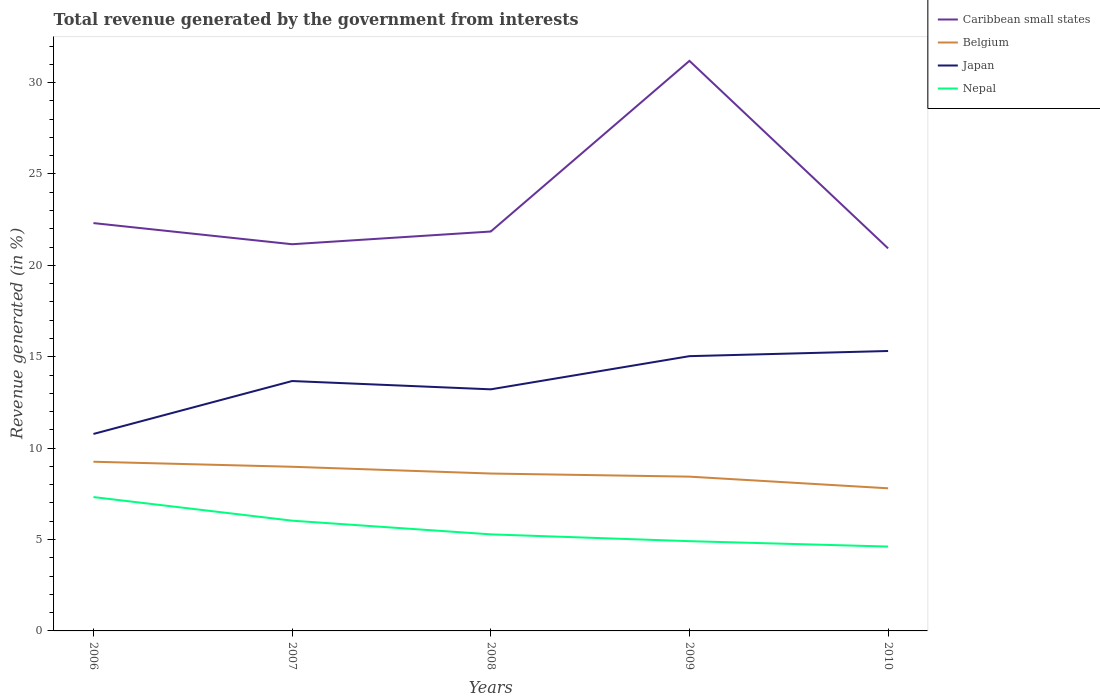How many different coloured lines are there?
Offer a very short reply. 4. Does the line corresponding to Belgium intersect with the line corresponding to Japan?
Your response must be concise. No. Is the number of lines equal to the number of legend labels?
Your answer should be compact. Yes. Across all years, what is the maximum total revenue generated in Caribbean small states?
Offer a terse response. 20.93. In which year was the total revenue generated in Nepal maximum?
Your response must be concise. 2010. What is the total total revenue generated in Caribbean small states in the graph?
Your response must be concise. 1.38. What is the difference between the highest and the second highest total revenue generated in Nepal?
Offer a very short reply. 2.71. Is the total revenue generated in Belgium strictly greater than the total revenue generated in Japan over the years?
Your answer should be very brief. Yes. How many lines are there?
Offer a terse response. 4. What is the difference between two consecutive major ticks on the Y-axis?
Provide a succinct answer. 5. Are the values on the major ticks of Y-axis written in scientific E-notation?
Provide a short and direct response. No. Does the graph contain any zero values?
Offer a very short reply. No. Where does the legend appear in the graph?
Your answer should be compact. Top right. How many legend labels are there?
Your answer should be compact. 4. What is the title of the graph?
Ensure brevity in your answer.  Total revenue generated by the government from interests. What is the label or title of the Y-axis?
Ensure brevity in your answer.  Revenue generated (in %). What is the Revenue generated (in %) in Caribbean small states in 2006?
Provide a short and direct response. 22.31. What is the Revenue generated (in %) of Belgium in 2006?
Offer a very short reply. 9.26. What is the Revenue generated (in %) in Japan in 2006?
Your answer should be very brief. 10.78. What is the Revenue generated (in %) of Nepal in 2006?
Ensure brevity in your answer.  7.32. What is the Revenue generated (in %) in Caribbean small states in 2007?
Provide a succinct answer. 21.16. What is the Revenue generated (in %) of Belgium in 2007?
Provide a succinct answer. 8.98. What is the Revenue generated (in %) of Japan in 2007?
Your answer should be very brief. 13.67. What is the Revenue generated (in %) of Nepal in 2007?
Provide a short and direct response. 6.03. What is the Revenue generated (in %) of Caribbean small states in 2008?
Make the answer very short. 21.85. What is the Revenue generated (in %) in Belgium in 2008?
Provide a short and direct response. 8.61. What is the Revenue generated (in %) of Japan in 2008?
Your response must be concise. 13.22. What is the Revenue generated (in %) in Nepal in 2008?
Your answer should be very brief. 5.28. What is the Revenue generated (in %) in Caribbean small states in 2009?
Give a very brief answer. 31.19. What is the Revenue generated (in %) of Belgium in 2009?
Offer a terse response. 8.44. What is the Revenue generated (in %) in Japan in 2009?
Provide a succinct answer. 15.03. What is the Revenue generated (in %) of Nepal in 2009?
Your answer should be very brief. 4.91. What is the Revenue generated (in %) of Caribbean small states in 2010?
Your answer should be very brief. 20.93. What is the Revenue generated (in %) in Belgium in 2010?
Your answer should be compact. 7.8. What is the Revenue generated (in %) of Japan in 2010?
Your answer should be compact. 15.32. What is the Revenue generated (in %) in Nepal in 2010?
Make the answer very short. 4.62. Across all years, what is the maximum Revenue generated (in %) in Caribbean small states?
Provide a succinct answer. 31.19. Across all years, what is the maximum Revenue generated (in %) of Belgium?
Provide a short and direct response. 9.26. Across all years, what is the maximum Revenue generated (in %) in Japan?
Keep it short and to the point. 15.32. Across all years, what is the maximum Revenue generated (in %) of Nepal?
Your response must be concise. 7.32. Across all years, what is the minimum Revenue generated (in %) in Caribbean small states?
Ensure brevity in your answer.  20.93. Across all years, what is the minimum Revenue generated (in %) of Belgium?
Offer a terse response. 7.8. Across all years, what is the minimum Revenue generated (in %) of Japan?
Keep it short and to the point. 10.78. Across all years, what is the minimum Revenue generated (in %) in Nepal?
Offer a terse response. 4.62. What is the total Revenue generated (in %) of Caribbean small states in the graph?
Your answer should be very brief. 117.44. What is the total Revenue generated (in %) of Belgium in the graph?
Give a very brief answer. 43.09. What is the total Revenue generated (in %) of Japan in the graph?
Your answer should be compact. 68.01. What is the total Revenue generated (in %) of Nepal in the graph?
Offer a very short reply. 28.16. What is the difference between the Revenue generated (in %) in Caribbean small states in 2006 and that in 2007?
Offer a terse response. 1.16. What is the difference between the Revenue generated (in %) in Belgium in 2006 and that in 2007?
Your response must be concise. 0.28. What is the difference between the Revenue generated (in %) of Japan in 2006 and that in 2007?
Give a very brief answer. -2.9. What is the difference between the Revenue generated (in %) in Nepal in 2006 and that in 2007?
Your answer should be compact. 1.29. What is the difference between the Revenue generated (in %) in Caribbean small states in 2006 and that in 2008?
Keep it short and to the point. 0.46. What is the difference between the Revenue generated (in %) of Belgium in 2006 and that in 2008?
Give a very brief answer. 0.65. What is the difference between the Revenue generated (in %) in Japan in 2006 and that in 2008?
Provide a short and direct response. -2.44. What is the difference between the Revenue generated (in %) of Nepal in 2006 and that in 2008?
Your response must be concise. 2.04. What is the difference between the Revenue generated (in %) of Caribbean small states in 2006 and that in 2009?
Your answer should be compact. -8.88. What is the difference between the Revenue generated (in %) of Belgium in 2006 and that in 2009?
Your answer should be very brief. 0.82. What is the difference between the Revenue generated (in %) in Japan in 2006 and that in 2009?
Offer a very short reply. -4.26. What is the difference between the Revenue generated (in %) of Nepal in 2006 and that in 2009?
Your answer should be compact. 2.41. What is the difference between the Revenue generated (in %) of Caribbean small states in 2006 and that in 2010?
Give a very brief answer. 1.38. What is the difference between the Revenue generated (in %) in Belgium in 2006 and that in 2010?
Your answer should be very brief. 1.45. What is the difference between the Revenue generated (in %) in Japan in 2006 and that in 2010?
Give a very brief answer. -4.54. What is the difference between the Revenue generated (in %) in Nepal in 2006 and that in 2010?
Offer a terse response. 2.71. What is the difference between the Revenue generated (in %) in Caribbean small states in 2007 and that in 2008?
Offer a very short reply. -0.7. What is the difference between the Revenue generated (in %) in Belgium in 2007 and that in 2008?
Make the answer very short. 0.37. What is the difference between the Revenue generated (in %) in Japan in 2007 and that in 2008?
Give a very brief answer. 0.45. What is the difference between the Revenue generated (in %) of Nepal in 2007 and that in 2008?
Offer a very short reply. 0.75. What is the difference between the Revenue generated (in %) in Caribbean small states in 2007 and that in 2009?
Offer a very short reply. -10.03. What is the difference between the Revenue generated (in %) of Belgium in 2007 and that in 2009?
Your answer should be very brief. 0.54. What is the difference between the Revenue generated (in %) of Japan in 2007 and that in 2009?
Give a very brief answer. -1.36. What is the difference between the Revenue generated (in %) of Nepal in 2007 and that in 2009?
Provide a succinct answer. 1.12. What is the difference between the Revenue generated (in %) in Caribbean small states in 2007 and that in 2010?
Give a very brief answer. 0.23. What is the difference between the Revenue generated (in %) of Belgium in 2007 and that in 2010?
Make the answer very short. 1.18. What is the difference between the Revenue generated (in %) in Japan in 2007 and that in 2010?
Offer a very short reply. -1.64. What is the difference between the Revenue generated (in %) in Nepal in 2007 and that in 2010?
Your answer should be very brief. 1.42. What is the difference between the Revenue generated (in %) in Caribbean small states in 2008 and that in 2009?
Your answer should be compact. -9.34. What is the difference between the Revenue generated (in %) in Belgium in 2008 and that in 2009?
Give a very brief answer. 0.17. What is the difference between the Revenue generated (in %) in Japan in 2008 and that in 2009?
Give a very brief answer. -1.82. What is the difference between the Revenue generated (in %) of Nepal in 2008 and that in 2009?
Offer a very short reply. 0.37. What is the difference between the Revenue generated (in %) of Caribbean small states in 2008 and that in 2010?
Your answer should be very brief. 0.92. What is the difference between the Revenue generated (in %) of Belgium in 2008 and that in 2010?
Make the answer very short. 0.81. What is the difference between the Revenue generated (in %) of Japan in 2008 and that in 2010?
Provide a short and direct response. -2.1. What is the difference between the Revenue generated (in %) in Nepal in 2008 and that in 2010?
Ensure brevity in your answer.  0.67. What is the difference between the Revenue generated (in %) of Caribbean small states in 2009 and that in 2010?
Offer a terse response. 10.26. What is the difference between the Revenue generated (in %) of Belgium in 2009 and that in 2010?
Offer a very short reply. 0.64. What is the difference between the Revenue generated (in %) of Japan in 2009 and that in 2010?
Offer a very short reply. -0.28. What is the difference between the Revenue generated (in %) in Nepal in 2009 and that in 2010?
Keep it short and to the point. 0.3. What is the difference between the Revenue generated (in %) of Caribbean small states in 2006 and the Revenue generated (in %) of Belgium in 2007?
Provide a short and direct response. 13.33. What is the difference between the Revenue generated (in %) of Caribbean small states in 2006 and the Revenue generated (in %) of Japan in 2007?
Provide a succinct answer. 8.64. What is the difference between the Revenue generated (in %) in Caribbean small states in 2006 and the Revenue generated (in %) in Nepal in 2007?
Offer a very short reply. 16.28. What is the difference between the Revenue generated (in %) of Belgium in 2006 and the Revenue generated (in %) of Japan in 2007?
Provide a succinct answer. -4.42. What is the difference between the Revenue generated (in %) of Belgium in 2006 and the Revenue generated (in %) of Nepal in 2007?
Offer a very short reply. 3.22. What is the difference between the Revenue generated (in %) in Japan in 2006 and the Revenue generated (in %) in Nepal in 2007?
Ensure brevity in your answer.  4.74. What is the difference between the Revenue generated (in %) of Caribbean small states in 2006 and the Revenue generated (in %) of Belgium in 2008?
Offer a very short reply. 13.7. What is the difference between the Revenue generated (in %) in Caribbean small states in 2006 and the Revenue generated (in %) in Japan in 2008?
Give a very brief answer. 9.1. What is the difference between the Revenue generated (in %) in Caribbean small states in 2006 and the Revenue generated (in %) in Nepal in 2008?
Offer a terse response. 17.03. What is the difference between the Revenue generated (in %) in Belgium in 2006 and the Revenue generated (in %) in Japan in 2008?
Make the answer very short. -3.96. What is the difference between the Revenue generated (in %) of Belgium in 2006 and the Revenue generated (in %) of Nepal in 2008?
Your response must be concise. 3.97. What is the difference between the Revenue generated (in %) in Japan in 2006 and the Revenue generated (in %) in Nepal in 2008?
Offer a terse response. 5.49. What is the difference between the Revenue generated (in %) in Caribbean small states in 2006 and the Revenue generated (in %) in Belgium in 2009?
Provide a succinct answer. 13.87. What is the difference between the Revenue generated (in %) in Caribbean small states in 2006 and the Revenue generated (in %) in Japan in 2009?
Keep it short and to the point. 7.28. What is the difference between the Revenue generated (in %) in Caribbean small states in 2006 and the Revenue generated (in %) in Nepal in 2009?
Provide a succinct answer. 17.4. What is the difference between the Revenue generated (in %) of Belgium in 2006 and the Revenue generated (in %) of Japan in 2009?
Provide a succinct answer. -5.78. What is the difference between the Revenue generated (in %) of Belgium in 2006 and the Revenue generated (in %) of Nepal in 2009?
Offer a terse response. 4.35. What is the difference between the Revenue generated (in %) of Japan in 2006 and the Revenue generated (in %) of Nepal in 2009?
Provide a succinct answer. 5.86. What is the difference between the Revenue generated (in %) in Caribbean small states in 2006 and the Revenue generated (in %) in Belgium in 2010?
Ensure brevity in your answer.  14.51. What is the difference between the Revenue generated (in %) in Caribbean small states in 2006 and the Revenue generated (in %) in Japan in 2010?
Ensure brevity in your answer.  7. What is the difference between the Revenue generated (in %) of Caribbean small states in 2006 and the Revenue generated (in %) of Nepal in 2010?
Make the answer very short. 17.7. What is the difference between the Revenue generated (in %) of Belgium in 2006 and the Revenue generated (in %) of Japan in 2010?
Ensure brevity in your answer.  -6.06. What is the difference between the Revenue generated (in %) in Belgium in 2006 and the Revenue generated (in %) in Nepal in 2010?
Your response must be concise. 4.64. What is the difference between the Revenue generated (in %) of Japan in 2006 and the Revenue generated (in %) of Nepal in 2010?
Give a very brief answer. 6.16. What is the difference between the Revenue generated (in %) of Caribbean small states in 2007 and the Revenue generated (in %) of Belgium in 2008?
Ensure brevity in your answer.  12.55. What is the difference between the Revenue generated (in %) in Caribbean small states in 2007 and the Revenue generated (in %) in Japan in 2008?
Your answer should be very brief. 7.94. What is the difference between the Revenue generated (in %) in Caribbean small states in 2007 and the Revenue generated (in %) in Nepal in 2008?
Keep it short and to the point. 15.87. What is the difference between the Revenue generated (in %) of Belgium in 2007 and the Revenue generated (in %) of Japan in 2008?
Provide a short and direct response. -4.24. What is the difference between the Revenue generated (in %) in Belgium in 2007 and the Revenue generated (in %) in Nepal in 2008?
Give a very brief answer. 3.7. What is the difference between the Revenue generated (in %) of Japan in 2007 and the Revenue generated (in %) of Nepal in 2008?
Your answer should be compact. 8.39. What is the difference between the Revenue generated (in %) in Caribbean small states in 2007 and the Revenue generated (in %) in Belgium in 2009?
Provide a succinct answer. 12.72. What is the difference between the Revenue generated (in %) in Caribbean small states in 2007 and the Revenue generated (in %) in Japan in 2009?
Give a very brief answer. 6.12. What is the difference between the Revenue generated (in %) in Caribbean small states in 2007 and the Revenue generated (in %) in Nepal in 2009?
Give a very brief answer. 16.25. What is the difference between the Revenue generated (in %) in Belgium in 2007 and the Revenue generated (in %) in Japan in 2009?
Offer a terse response. -6.05. What is the difference between the Revenue generated (in %) in Belgium in 2007 and the Revenue generated (in %) in Nepal in 2009?
Your answer should be compact. 4.07. What is the difference between the Revenue generated (in %) of Japan in 2007 and the Revenue generated (in %) of Nepal in 2009?
Provide a succinct answer. 8.76. What is the difference between the Revenue generated (in %) in Caribbean small states in 2007 and the Revenue generated (in %) in Belgium in 2010?
Give a very brief answer. 13.35. What is the difference between the Revenue generated (in %) in Caribbean small states in 2007 and the Revenue generated (in %) in Japan in 2010?
Your response must be concise. 5.84. What is the difference between the Revenue generated (in %) of Caribbean small states in 2007 and the Revenue generated (in %) of Nepal in 2010?
Ensure brevity in your answer.  16.54. What is the difference between the Revenue generated (in %) of Belgium in 2007 and the Revenue generated (in %) of Japan in 2010?
Offer a terse response. -6.33. What is the difference between the Revenue generated (in %) of Belgium in 2007 and the Revenue generated (in %) of Nepal in 2010?
Ensure brevity in your answer.  4.37. What is the difference between the Revenue generated (in %) of Japan in 2007 and the Revenue generated (in %) of Nepal in 2010?
Give a very brief answer. 9.06. What is the difference between the Revenue generated (in %) in Caribbean small states in 2008 and the Revenue generated (in %) in Belgium in 2009?
Your answer should be very brief. 13.41. What is the difference between the Revenue generated (in %) in Caribbean small states in 2008 and the Revenue generated (in %) in Japan in 2009?
Your answer should be very brief. 6.82. What is the difference between the Revenue generated (in %) in Caribbean small states in 2008 and the Revenue generated (in %) in Nepal in 2009?
Give a very brief answer. 16.94. What is the difference between the Revenue generated (in %) of Belgium in 2008 and the Revenue generated (in %) of Japan in 2009?
Make the answer very short. -6.42. What is the difference between the Revenue generated (in %) in Belgium in 2008 and the Revenue generated (in %) in Nepal in 2009?
Give a very brief answer. 3.7. What is the difference between the Revenue generated (in %) in Japan in 2008 and the Revenue generated (in %) in Nepal in 2009?
Offer a terse response. 8.31. What is the difference between the Revenue generated (in %) in Caribbean small states in 2008 and the Revenue generated (in %) in Belgium in 2010?
Give a very brief answer. 14.05. What is the difference between the Revenue generated (in %) of Caribbean small states in 2008 and the Revenue generated (in %) of Japan in 2010?
Your response must be concise. 6.54. What is the difference between the Revenue generated (in %) of Caribbean small states in 2008 and the Revenue generated (in %) of Nepal in 2010?
Keep it short and to the point. 17.24. What is the difference between the Revenue generated (in %) in Belgium in 2008 and the Revenue generated (in %) in Japan in 2010?
Your response must be concise. -6.7. What is the difference between the Revenue generated (in %) in Belgium in 2008 and the Revenue generated (in %) in Nepal in 2010?
Give a very brief answer. 4. What is the difference between the Revenue generated (in %) of Japan in 2008 and the Revenue generated (in %) of Nepal in 2010?
Your answer should be very brief. 8.6. What is the difference between the Revenue generated (in %) of Caribbean small states in 2009 and the Revenue generated (in %) of Belgium in 2010?
Make the answer very short. 23.39. What is the difference between the Revenue generated (in %) in Caribbean small states in 2009 and the Revenue generated (in %) in Japan in 2010?
Keep it short and to the point. 15.87. What is the difference between the Revenue generated (in %) in Caribbean small states in 2009 and the Revenue generated (in %) in Nepal in 2010?
Your response must be concise. 26.57. What is the difference between the Revenue generated (in %) in Belgium in 2009 and the Revenue generated (in %) in Japan in 2010?
Provide a succinct answer. -6.87. What is the difference between the Revenue generated (in %) in Belgium in 2009 and the Revenue generated (in %) in Nepal in 2010?
Provide a short and direct response. 3.83. What is the difference between the Revenue generated (in %) of Japan in 2009 and the Revenue generated (in %) of Nepal in 2010?
Your answer should be very brief. 10.42. What is the average Revenue generated (in %) of Caribbean small states per year?
Make the answer very short. 23.49. What is the average Revenue generated (in %) of Belgium per year?
Keep it short and to the point. 8.62. What is the average Revenue generated (in %) in Japan per year?
Provide a succinct answer. 13.6. What is the average Revenue generated (in %) of Nepal per year?
Offer a very short reply. 5.63. In the year 2006, what is the difference between the Revenue generated (in %) of Caribbean small states and Revenue generated (in %) of Belgium?
Offer a very short reply. 13.06. In the year 2006, what is the difference between the Revenue generated (in %) in Caribbean small states and Revenue generated (in %) in Japan?
Your answer should be compact. 11.54. In the year 2006, what is the difference between the Revenue generated (in %) of Caribbean small states and Revenue generated (in %) of Nepal?
Your response must be concise. 14.99. In the year 2006, what is the difference between the Revenue generated (in %) in Belgium and Revenue generated (in %) in Japan?
Provide a short and direct response. -1.52. In the year 2006, what is the difference between the Revenue generated (in %) in Belgium and Revenue generated (in %) in Nepal?
Your answer should be very brief. 1.93. In the year 2006, what is the difference between the Revenue generated (in %) in Japan and Revenue generated (in %) in Nepal?
Offer a very short reply. 3.45. In the year 2007, what is the difference between the Revenue generated (in %) in Caribbean small states and Revenue generated (in %) in Belgium?
Provide a succinct answer. 12.18. In the year 2007, what is the difference between the Revenue generated (in %) of Caribbean small states and Revenue generated (in %) of Japan?
Keep it short and to the point. 7.48. In the year 2007, what is the difference between the Revenue generated (in %) of Caribbean small states and Revenue generated (in %) of Nepal?
Your response must be concise. 15.12. In the year 2007, what is the difference between the Revenue generated (in %) of Belgium and Revenue generated (in %) of Japan?
Provide a succinct answer. -4.69. In the year 2007, what is the difference between the Revenue generated (in %) of Belgium and Revenue generated (in %) of Nepal?
Keep it short and to the point. 2.95. In the year 2007, what is the difference between the Revenue generated (in %) in Japan and Revenue generated (in %) in Nepal?
Offer a very short reply. 7.64. In the year 2008, what is the difference between the Revenue generated (in %) in Caribbean small states and Revenue generated (in %) in Belgium?
Offer a very short reply. 13.24. In the year 2008, what is the difference between the Revenue generated (in %) in Caribbean small states and Revenue generated (in %) in Japan?
Your answer should be very brief. 8.63. In the year 2008, what is the difference between the Revenue generated (in %) of Caribbean small states and Revenue generated (in %) of Nepal?
Ensure brevity in your answer.  16.57. In the year 2008, what is the difference between the Revenue generated (in %) of Belgium and Revenue generated (in %) of Japan?
Give a very brief answer. -4.61. In the year 2008, what is the difference between the Revenue generated (in %) in Belgium and Revenue generated (in %) in Nepal?
Give a very brief answer. 3.33. In the year 2008, what is the difference between the Revenue generated (in %) of Japan and Revenue generated (in %) of Nepal?
Give a very brief answer. 7.93. In the year 2009, what is the difference between the Revenue generated (in %) of Caribbean small states and Revenue generated (in %) of Belgium?
Give a very brief answer. 22.75. In the year 2009, what is the difference between the Revenue generated (in %) of Caribbean small states and Revenue generated (in %) of Japan?
Ensure brevity in your answer.  16.16. In the year 2009, what is the difference between the Revenue generated (in %) in Caribbean small states and Revenue generated (in %) in Nepal?
Ensure brevity in your answer.  26.28. In the year 2009, what is the difference between the Revenue generated (in %) of Belgium and Revenue generated (in %) of Japan?
Provide a succinct answer. -6.59. In the year 2009, what is the difference between the Revenue generated (in %) in Belgium and Revenue generated (in %) in Nepal?
Your answer should be compact. 3.53. In the year 2009, what is the difference between the Revenue generated (in %) in Japan and Revenue generated (in %) in Nepal?
Keep it short and to the point. 10.12. In the year 2010, what is the difference between the Revenue generated (in %) of Caribbean small states and Revenue generated (in %) of Belgium?
Ensure brevity in your answer.  13.13. In the year 2010, what is the difference between the Revenue generated (in %) in Caribbean small states and Revenue generated (in %) in Japan?
Offer a very short reply. 5.61. In the year 2010, what is the difference between the Revenue generated (in %) in Caribbean small states and Revenue generated (in %) in Nepal?
Your response must be concise. 16.31. In the year 2010, what is the difference between the Revenue generated (in %) of Belgium and Revenue generated (in %) of Japan?
Give a very brief answer. -7.51. In the year 2010, what is the difference between the Revenue generated (in %) in Belgium and Revenue generated (in %) in Nepal?
Make the answer very short. 3.19. In the year 2010, what is the difference between the Revenue generated (in %) of Japan and Revenue generated (in %) of Nepal?
Ensure brevity in your answer.  10.7. What is the ratio of the Revenue generated (in %) in Caribbean small states in 2006 to that in 2007?
Give a very brief answer. 1.05. What is the ratio of the Revenue generated (in %) in Belgium in 2006 to that in 2007?
Ensure brevity in your answer.  1.03. What is the ratio of the Revenue generated (in %) in Japan in 2006 to that in 2007?
Provide a short and direct response. 0.79. What is the ratio of the Revenue generated (in %) in Nepal in 2006 to that in 2007?
Offer a terse response. 1.21. What is the ratio of the Revenue generated (in %) in Caribbean small states in 2006 to that in 2008?
Ensure brevity in your answer.  1.02. What is the ratio of the Revenue generated (in %) in Belgium in 2006 to that in 2008?
Give a very brief answer. 1.07. What is the ratio of the Revenue generated (in %) in Japan in 2006 to that in 2008?
Your answer should be very brief. 0.82. What is the ratio of the Revenue generated (in %) in Nepal in 2006 to that in 2008?
Offer a very short reply. 1.39. What is the ratio of the Revenue generated (in %) in Caribbean small states in 2006 to that in 2009?
Make the answer very short. 0.72. What is the ratio of the Revenue generated (in %) of Belgium in 2006 to that in 2009?
Provide a succinct answer. 1.1. What is the ratio of the Revenue generated (in %) in Japan in 2006 to that in 2009?
Offer a terse response. 0.72. What is the ratio of the Revenue generated (in %) in Nepal in 2006 to that in 2009?
Offer a terse response. 1.49. What is the ratio of the Revenue generated (in %) in Caribbean small states in 2006 to that in 2010?
Keep it short and to the point. 1.07. What is the ratio of the Revenue generated (in %) of Belgium in 2006 to that in 2010?
Your response must be concise. 1.19. What is the ratio of the Revenue generated (in %) of Japan in 2006 to that in 2010?
Make the answer very short. 0.7. What is the ratio of the Revenue generated (in %) of Nepal in 2006 to that in 2010?
Provide a succinct answer. 1.59. What is the ratio of the Revenue generated (in %) of Caribbean small states in 2007 to that in 2008?
Provide a short and direct response. 0.97. What is the ratio of the Revenue generated (in %) in Belgium in 2007 to that in 2008?
Your answer should be very brief. 1.04. What is the ratio of the Revenue generated (in %) in Japan in 2007 to that in 2008?
Offer a very short reply. 1.03. What is the ratio of the Revenue generated (in %) of Nepal in 2007 to that in 2008?
Offer a very short reply. 1.14. What is the ratio of the Revenue generated (in %) in Caribbean small states in 2007 to that in 2009?
Provide a short and direct response. 0.68. What is the ratio of the Revenue generated (in %) of Belgium in 2007 to that in 2009?
Offer a terse response. 1.06. What is the ratio of the Revenue generated (in %) in Japan in 2007 to that in 2009?
Make the answer very short. 0.91. What is the ratio of the Revenue generated (in %) of Nepal in 2007 to that in 2009?
Ensure brevity in your answer.  1.23. What is the ratio of the Revenue generated (in %) in Caribbean small states in 2007 to that in 2010?
Ensure brevity in your answer.  1.01. What is the ratio of the Revenue generated (in %) in Belgium in 2007 to that in 2010?
Your answer should be compact. 1.15. What is the ratio of the Revenue generated (in %) in Japan in 2007 to that in 2010?
Provide a succinct answer. 0.89. What is the ratio of the Revenue generated (in %) in Nepal in 2007 to that in 2010?
Give a very brief answer. 1.31. What is the ratio of the Revenue generated (in %) in Caribbean small states in 2008 to that in 2009?
Your response must be concise. 0.7. What is the ratio of the Revenue generated (in %) of Belgium in 2008 to that in 2009?
Provide a short and direct response. 1.02. What is the ratio of the Revenue generated (in %) of Japan in 2008 to that in 2009?
Keep it short and to the point. 0.88. What is the ratio of the Revenue generated (in %) of Nepal in 2008 to that in 2009?
Offer a very short reply. 1.08. What is the ratio of the Revenue generated (in %) in Caribbean small states in 2008 to that in 2010?
Your answer should be very brief. 1.04. What is the ratio of the Revenue generated (in %) in Belgium in 2008 to that in 2010?
Your response must be concise. 1.1. What is the ratio of the Revenue generated (in %) of Japan in 2008 to that in 2010?
Give a very brief answer. 0.86. What is the ratio of the Revenue generated (in %) in Nepal in 2008 to that in 2010?
Offer a terse response. 1.14. What is the ratio of the Revenue generated (in %) of Caribbean small states in 2009 to that in 2010?
Provide a short and direct response. 1.49. What is the ratio of the Revenue generated (in %) of Belgium in 2009 to that in 2010?
Offer a terse response. 1.08. What is the ratio of the Revenue generated (in %) in Japan in 2009 to that in 2010?
Your answer should be compact. 0.98. What is the ratio of the Revenue generated (in %) in Nepal in 2009 to that in 2010?
Your answer should be compact. 1.06. What is the difference between the highest and the second highest Revenue generated (in %) of Caribbean small states?
Your response must be concise. 8.88. What is the difference between the highest and the second highest Revenue generated (in %) in Belgium?
Make the answer very short. 0.28. What is the difference between the highest and the second highest Revenue generated (in %) in Japan?
Ensure brevity in your answer.  0.28. What is the difference between the highest and the second highest Revenue generated (in %) in Nepal?
Your answer should be compact. 1.29. What is the difference between the highest and the lowest Revenue generated (in %) in Caribbean small states?
Your answer should be very brief. 10.26. What is the difference between the highest and the lowest Revenue generated (in %) of Belgium?
Provide a short and direct response. 1.45. What is the difference between the highest and the lowest Revenue generated (in %) of Japan?
Provide a short and direct response. 4.54. What is the difference between the highest and the lowest Revenue generated (in %) in Nepal?
Your answer should be compact. 2.71. 